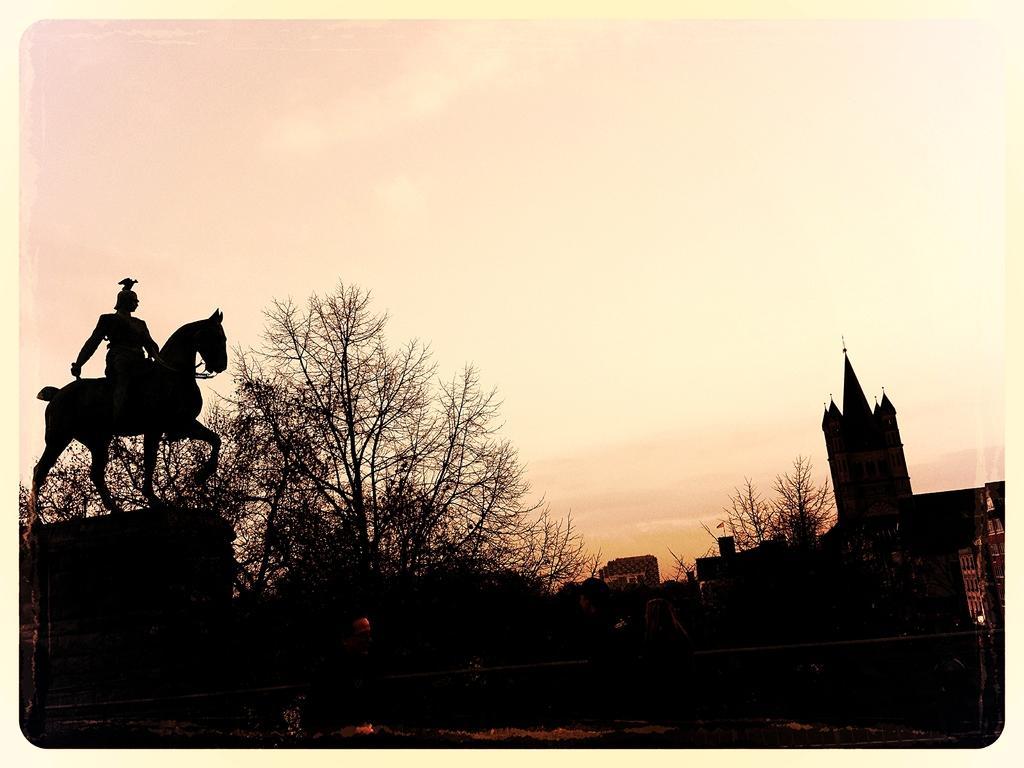Could you give a brief overview of what you see in this image? Front of the image it is dark and we can see a sculpture of a person sitting on horse,trees and buildings. In the background we can see the sky. 